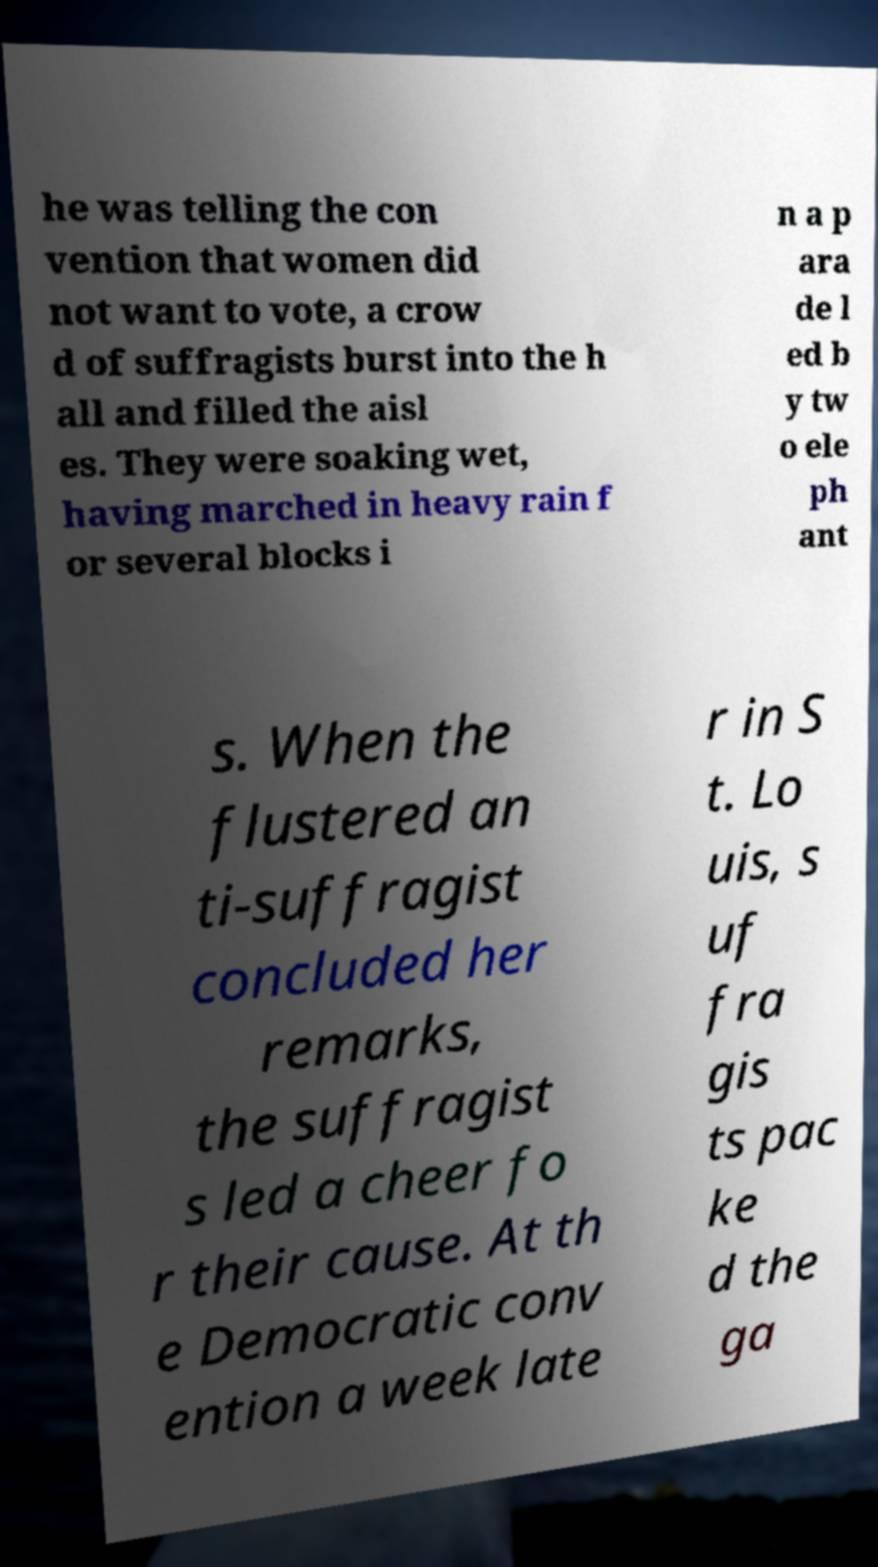For documentation purposes, I need the text within this image transcribed. Could you provide that? he was telling the con vention that women did not want to vote, a crow d of suffragists burst into the h all and filled the aisl es. They were soaking wet, having marched in heavy rain f or several blocks i n a p ara de l ed b y tw o ele ph ant s. When the flustered an ti-suffragist concluded her remarks, the suffragist s led a cheer fo r their cause. At th e Democratic conv ention a week late r in S t. Lo uis, s uf fra gis ts pac ke d the ga 